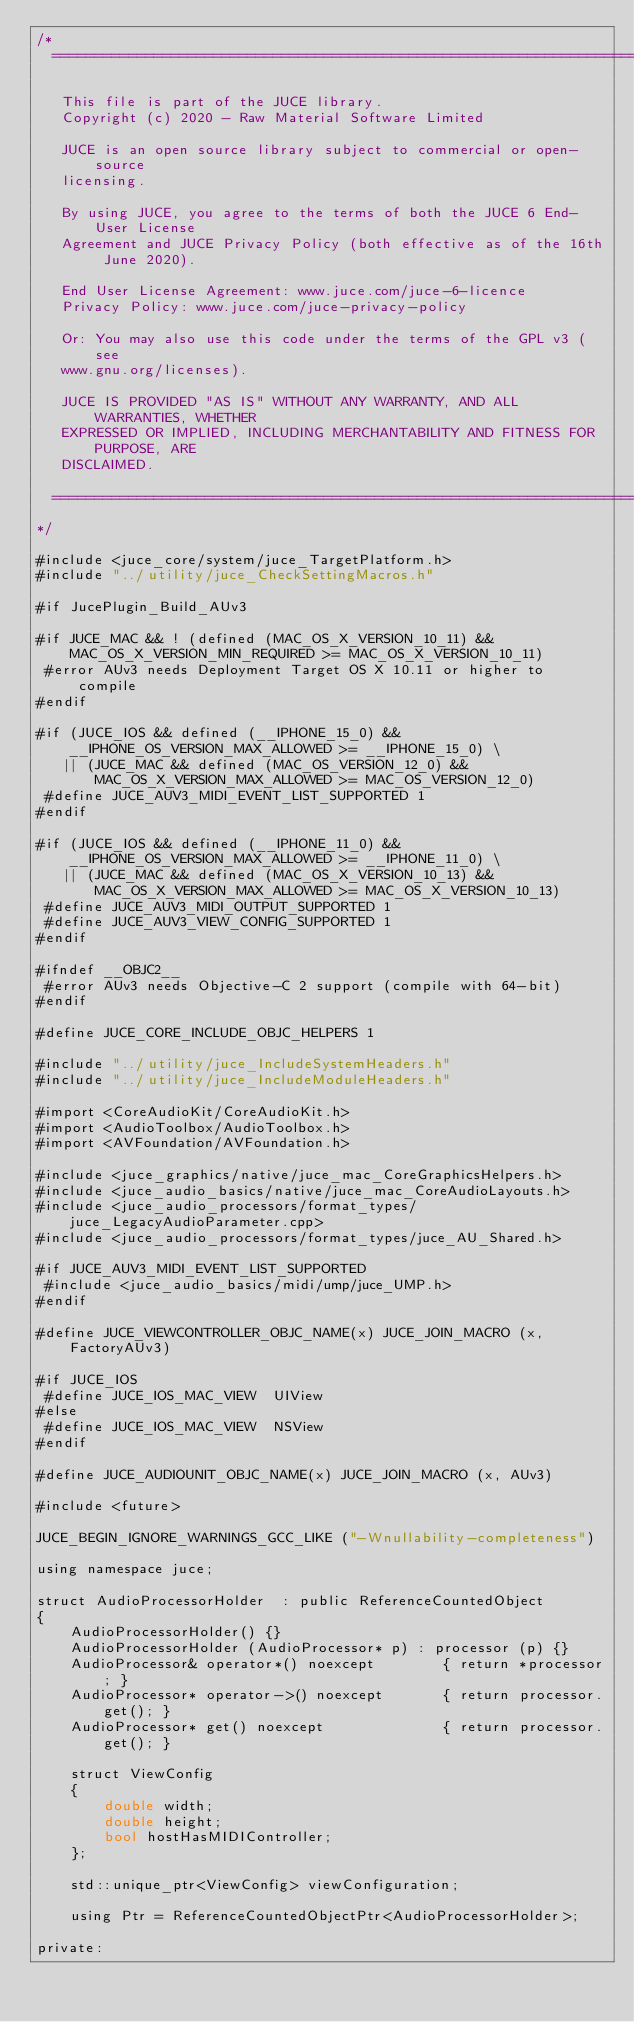Convert code to text. <code><loc_0><loc_0><loc_500><loc_500><_ObjectiveC_>/*
  ==============================================================================

   This file is part of the JUCE library.
   Copyright (c) 2020 - Raw Material Software Limited

   JUCE is an open source library subject to commercial or open-source
   licensing.

   By using JUCE, you agree to the terms of both the JUCE 6 End-User License
   Agreement and JUCE Privacy Policy (both effective as of the 16th June 2020).

   End User License Agreement: www.juce.com/juce-6-licence
   Privacy Policy: www.juce.com/juce-privacy-policy

   Or: You may also use this code under the terms of the GPL v3 (see
   www.gnu.org/licenses).

   JUCE IS PROVIDED "AS IS" WITHOUT ANY WARRANTY, AND ALL WARRANTIES, WHETHER
   EXPRESSED OR IMPLIED, INCLUDING MERCHANTABILITY AND FITNESS FOR PURPOSE, ARE
   DISCLAIMED.

  ==============================================================================
*/

#include <juce_core/system/juce_TargetPlatform.h>
#include "../utility/juce_CheckSettingMacros.h"

#if JucePlugin_Build_AUv3

#if JUCE_MAC && ! (defined (MAC_OS_X_VERSION_10_11) && MAC_OS_X_VERSION_MIN_REQUIRED >= MAC_OS_X_VERSION_10_11)
 #error AUv3 needs Deployment Target OS X 10.11 or higher to compile
#endif

#if (JUCE_IOS && defined (__IPHONE_15_0) && __IPHONE_OS_VERSION_MAX_ALLOWED >= __IPHONE_15_0) \
   || (JUCE_MAC && defined (MAC_OS_VERSION_12_0) && MAC_OS_X_VERSION_MAX_ALLOWED >= MAC_OS_VERSION_12_0)
 #define JUCE_AUV3_MIDI_EVENT_LIST_SUPPORTED 1
#endif

#if (JUCE_IOS && defined (__IPHONE_11_0) && __IPHONE_OS_VERSION_MAX_ALLOWED >= __IPHONE_11_0) \
   || (JUCE_MAC && defined (MAC_OS_X_VERSION_10_13) && MAC_OS_X_VERSION_MAX_ALLOWED >= MAC_OS_X_VERSION_10_13)
 #define JUCE_AUV3_MIDI_OUTPUT_SUPPORTED 1
 #define JUCE_AUV3_VIEW_CONFIG_SUPPORTED 1
#endif

#ifndef __OBJC2__
 #error AUv3 needs Objective-C 2 support (compile with 64-bit)
#endif

#define JUCE_CORE_INCLUDE_OBJC_HELPERS 1

#include "../utility/juce_IncludeSystemHeaders.h"
#include "../utility/juce_IncludeModuleHeaders.h"

#import <CoreAudioKit/CoreAudioKit.h>
#import <AudioToolbox/AudioToolbox.h>
#import <AVFoundation/AVFoundation.h>

#include <juce_graphics/native/juce_mac_CoreGraphicsHelpers.h>
#include <juce_audio_basics/native/juce_mac_CoreAudioLayouts.h>
#include <juce_audio_processors/format_types/juce_LegacyAudioParameter.cpp>
#include <juce_audio_processors/format_types/juce_AU_Shared.h>

#if JUCE_AUV3_MIDI_EVENT_LIST_SUPPORTED
 #include <juce_audio_basics/midi/ump/juce_UMP.h>
#endif

#define JUCE_VIEWCONTROLLER_OBJC_NAME(x) JUCE_JOIN_MACRO (x, FactoryAUv3)

#if JUCE_IOS
 #define JUCE_IOS_MAC_VIEW  UIView
#else
 #define JUCE_IOS_MAC_VIEW  NSView
#endif

#define JUCE_AUDIOUNIT_OBJC_NAME(x) JUCE_JOIN_MACRO (x, AUv3)

#include <future>

JUCE_BEGIN_IGNORE_WARNINGS_GCC_LIKE ("-Wnullability-completeness")

using namespace juce;

struct AudioProcessorHolder  : public ReferenceCountedObject
{
    AudioProcessorHolder() {}
    AudioProcessorHolder (AudioProcessor* p) : processor (p) {}
    AudioProcessor& operator*() noexcept        { return *processor; }
    AudioProcessor* operator->() noexcept       { return processor.get(); }
    AudioProcessor* get() noexcept              { return processor.get(); }

    struct ViewConfig
    {
        double width;
        double height;
        bool hostHasMIDIController;
    };

    std::unique_ptr<ViewConfig> viewConfiguration;

    using Ptr = ReferenceCountedObjectPtr<AudioProcessorHolder>;

private:</code> 